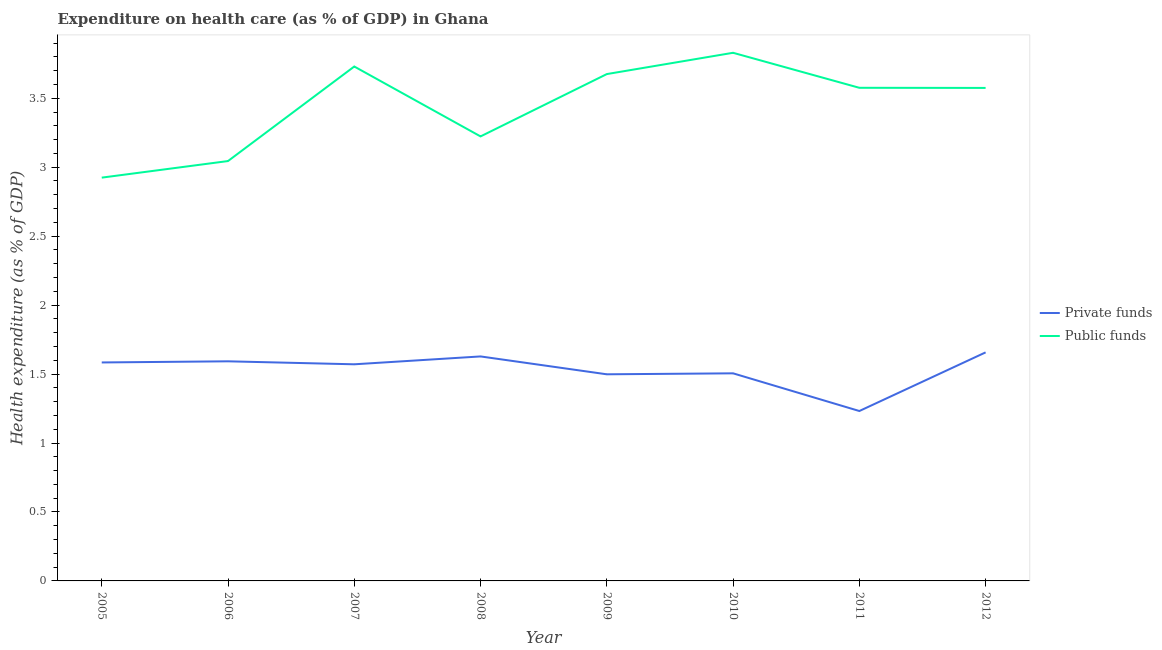How many different coloured lines are there?
Offer a terse response. 2. Does the line corresponding to amount of private funds spent in healthcare intersect with the line corresponding to amount of public funds spent in healthcare?
Offer a terse response. No. What is the amount of private funds spent in healthcare in 2011?
Your answer should be very brief. 1.23. Across all years, what is the maximum amount of public funds spent in healthcare?
Offer a terse response. 3.83. Across all years, what is the minimum amount of private funds spent in healthcare?
Make the answer very short. 1.23. In which year was the amount of private funds spent in healthcare maximum?
Ensure brevity in your answer.  2012. What is the total amount of private funds spent in healthcare in the graph?
Offer a very short reply. 12.27. What is the difference between the amount of public funds spent in healthcare in 2005 and that in 2011?
Provide a succinct answer. -0.65. What is the difference between the amount of public funds spent in healthcare in 2007 and the amount of private funds spent in healthcare in 2005?
Offer a terse response. 2.15. What is the average amount of public funds spent in healthcare per year?
Make the answer very short. 3.45. In the year 2012, what is the difference between the amount of private funds spent in healthcare and amount of public funds spent in healthcare?
Provide a short and direct response. -1.92. In how many years, is the amount of public funds spent in healthcare greater than 1.4 %?
Provide a short and direct response. 8. What is the ratio of the amount of public funds spent in healthcare in 2005 to that in 2009?
Your answer should be compact. 0.8. Is the difference between the amount of public funds spent in healthcare in 2006 and 2010 greater than the difference between the amount of private funds spent in healthcare in 2006 and 2010?
Keep it short and to the point. No. What is the difference between the highest and the second highest amount of public funds spent in healthcare?
Your response must be concise. 0.1. What is the difference between the highest and the lowest amount of private funds spent in healthcare?
Give a very brief answer. 0.43. In how many years, is the amount of private funds spent in healthcare greater than the average amount of private funds spent in healthcare taken over all years?
Your response must be concise. 5. Is the sum of the amount of private funds spent in healthcare in 2005 and 2012 greater than the maximum amount of public funds spent in healthcare across all years?
Provide a short and direct response. No. How many lines are there?
Provide a short and direct response. 2. Does the graph contain any zero values?
Keep it short and to the point. No. Does the graph contain grids?
Provide a succinct answer. No. How many legend labels are there?
Make the answer very short. 2. How are the legend labels stacked?
Your answer should be compact. Vertical. What is the title of the graph?
Give a very brief answer. Expenditure on health care (as % of GDP) in Ghana. What is the label or title of the Y-axis?
Your answer should be very brief. Health expenditure (as % of GDP). What is the Health expenditure (as % of GDP) of Private funds in 2005?
Offer a terse response. 1.58. What is the Health expenditure (as % of GDP) of Public funds in 2005?
Offer a very short reply. 2.92. What is the Health expenditure (as % of GDP) of Private funds in 2006?
Your answer should be compact. 1.59. What is the Health expenditure (as % of GDP) in Public funds in 2006?
Ensure brevity in your answer.  3.04. What is the Health expenditure (as % of GDP) in Private funds in 2007?
Your response must be concise. 1.57. What is the Health expenditure (as % of GDP) of Public funds in 2007?
Make the answer very short. 3.73. What is the Health expenditure (as % of GDP) of Private funds in 2008?
Your answer should be compact. 1.63. What is the Health expenditure (as % of GDP) of Public funds in 2008?
Offer a very short reply. 3.22. What is the Health expenditure (as % of GDP) in Private funds in 2009?
Ensure brevity in your answer.  1.5. What is the Health expenditure (as % of GDP) of Public funds in 2009?
Offer a very short reply. 3.67. What is the Health expenditure (as % of GDP) of Private funds in 2010?
Keep it short and to the point. 1.51. What is the Health expenditure (as % of GDP) of Public funds in 2010?
Make the answer very short. 3.83. What is the Health expenditure (as % of GDP) in Private funds in 2011?
Make the answer very short. 1.23. What is the Health expenditure (as % of GDP) of Public funds in 2011?
Offer a terse response. 3.58. What is the Health expenditure (as % of GDP) of Private funds in 2012?
Your response must be concise. 1.66. What is the Health expenditure (as % of GDP) in Public funds in 2012?
Offer a terse response. 3.57. Across all years, what is the maximum Health expenditure (as % of GDP) of Private funds?
Provide a succinct answer. 1.66. Across all years, what is the maximum Health expenditure (as % of GDP) in Public funds?
Offer a very short reply. 3.83. Across all years, what is the minimum Health expenditure (as % of GDP) in Private funds?
Provide a succinct answer. 1.23. Across all years, what is the minimum Health expenditure (as % of GDP) of Public funds?
Give a very brief answer. 2.92. What is the total Health expenditure (as % of GDP) of Private funds in the graph?
Give a very brief answer. 12.27. What is the total Health expenditure (as % of GDP) of Public funds in the graph?
Provide a short and direct response. 27.58. What is the difference between the Health expenditure (as % of GDP) in Private funds in 2005 and that in 2006?
Provide a succinct answer. -0.01. What is the difference between the Health expenditure (as % of GDP) of Public funds in 2005 and that in 2006?
Give a very brief answer. -0.12. What is the difference between the Health expenditure (as % of GDP) in Private funds in 2005 and that in 2007?
Give a very brief answer. 0.01. What is the difference between the Health expenditure (as % of GDP) of Public funds in 2005 and that in 2007?
Give a very brief answer. -0.81. What is the difference between the Health expenditure (as % of GDP) of Private funds in 2005 and that in 2008?
Keep it short and to the point. -0.04. What is the difference between the Health expenditure (as % of GDP) of Public funds in 2005 and that in 2008?
Offer a terse response. -0.3. What is the difference between the Health expenditure (as % of GDP) in Private funds in 2005 and that in 2009?
Your answer should be compact. 0.09. What is the difference between the Health expenditure (as % of GDP) in Public funds in 2005 and that in 2009?
Give a very brief answer. -0.75. What is the difference between the Health expenditure (as % of GDP) in Private funds in 2005 and that in 2010?
Give a very brief answer. 0.08. What is the difference between the Health expenditure (as % of GDP) in Public funds in 2005 and that in 2010?
Offer a terse response. -0.91. What is the difference between the Health expenditure (as % of GDP) of Private funds in 2005 and that in 2011?
Offer a terse response. 0.35. What is the difference between the Health expenditure (as % of GDP) of Public funds in 2005 and that in 2011?
Provide a succinct answer. -0.65. What is the difference between the Health expenditure (as % of GDP) of Private funds in 2005 and that in 2012?
Ensure brevity in your answer.  -0.07. What is the difference between the Health expenditure (as % of GDP) in Public funds in 2005 and that in 2012?
Your answer should be compact. -0.65. What is the difference between the Health expenditure (as % of GDP) of Private funds in 2006 and that in 2007?
Your answer should be very brief. 0.02. What is the difference between the Health expenditure (as % of GDP) of Public funds in 2006 and that in 2007?
Ensure brevity in your answer.  -0.69. What is the difference between the Health expenditure (as % of GDP) in Private funds in 2006 and that in 2008?
Your response must be concise. -0.04. What is the difference between the Health expenditure (as % of GDP) in Public funds in 2006 and that in 2008?
Provide a succinct answer. -0.18. What is the difference between the Health expenditure (as % of GDP) of Private funds in 2006 and that in 2009?
Ensure brevity in your answer.  0.09. What is the difference between the Health expenditure (as % of GDP) of Public funds in 2006 and that in 2009?
Give a very brief answer. -0.63. What is the difference between the Health expenditure (as % of GDP) in Private funds in 2006 and that in 2010?
Make the answer very short. 0.09. What is the difference between the Health expenditure (as % of GDP) of Public funds in 2006 and that in 2010?
Provide a short and direct response. -0.79. What is the difference between the Health expenditure (as % of GDP) in Private funds in 2006 and that in 2011?
Your answer should be compact. 0.36. What is the difference between the Health expenditure (as % of GDP) of Public funds in 2006 and that in 2011?
Your answer should be compact. -0.53. What is the difference between the Health expenditure (as % of GDP) of Private funds in 2006 and that in 2012?
Your answer should be very brief. -0.06. What is the difference between the Health expenditure (as % of GDP) in Public funds in 2006 and that in 2012?
Your answer should be compact. -0.53. What is the difference between the Health expenditure (as % of GDP) in Private funds in 2007 and that in 2008?
Keep it short and to the point. -0.06. What is the difference between the Health expenditure (as % of GDP) in Public funds in 2007 and that in 2008?
Your answer should be compact. 0.51. What is the difference between the Health expenditure (as % of GDP) in Private funds in 2007 and that in 2009?
Provide a short and direct response. 0.07. What is the difference between the Health expenditure (as % of GDP) in Public funds in 2007 and that in 2009?
Ensure brevity in your answer.  0.05. What is the difference between the Health expenditure (as % of GDP) in Private funds in 2007 and that in 2010?
Ensure brevity in your answer.  0.07. What is the difference between the Health expenditure (as % of GDP) of Public funds in 2007 and that in 2010?
Offer a terse response. -0.1. What is the difference between the Health expenditure (as % of GDP) of Private funds in 2007 and that in 2011?
Your response must be concise. 0.34. What is the difference between the Health expenditure (as % of GDP) of Public funds in 2007 and that in 2011?
Provide a short and direct response. 0.15. What is the difference between the Health expenditure (as % of GDP) of Private funds in 2007 and that in 2012?
Keep it short and to the point. -0.09. What is the difference between the Health expenditure (as % of GDP) in Public funds in 2007 and that in 2012?
Your answer should be very brief. 0.16. What is the difference between the Health expenditure (as % of GDP) in Private funds in 2008 and that in 2009?
Offer a terse response. 0.13. What is the difference between the Health expenditure (as % of GDP) of Public funds in 2008 and that in 2009?
Make the answer very short. -0.45. What is the difference between the Health expenditure (as % of GDP) in Private funds in 2008 and that in 2010?
Provide a succinct answer. 0.12. What is the difference between the Health expenditure (as % of GDP) of Public funds in 2008 and that in 2010?
Your response must be concise. -0.61. What is the difference between the Health expenditure (as % of GDP) in Private funds in 2008 and that in 2011?
Your answer should be compact. 0.4. What is the difference between the Health expenditure (as % of GDP) in Public funds in 2008 and that in 2011?
Provide a short and direct response. -0.35. What is the difference between the Health expenditure (as % of GDP) in Private funds in 2008 and that in 2012?
Offer a terse response. -0.03. What is the difference between the Health expenditure (as % of GDP) in Public funds in 2008 and that in 2012?
Make the answer very short. -0.35. What is the difference between the Health expenditure (as % of GDP) of Private funds in 2009 and that in 2010?
Your answer should be very brief. -0.01. What is the difference between the Health expenditure (as % of GDP) of Public funds in 2009 and that in 2010?
Your response must be concise. -0.15. What is the difference between the Health expenditure (as % of GDP) of Private funds in 2009 and that in 2011?
Provide a short and direct response. 0.27. What is the difference between the Health expenditure (as % of GDP) of Public funds in 2009 and that in 2011?
Make the answer very short. 0.1. What is the difference between the Health expenditure (as % of GDP) of Private funds in 2009 and that in 2012?
Offer a terse response. -0.16. What is the difference between the Health expenditure (as % of GDP) of Public funds in 2009 and that in 2012?
Your response must be concise. 0.1. What is the difference between the Health expenditure (as % of GDP) in Private funds in 2010 and that in 2011?
Ensure brevity in your answer.  0.27. What is the difference between the Health expenditure (as % of GDP) in Public funds in 2010 and that in 2011?
Ensure brevity in your answer.  0.25. What is the difference between the Health expenditure (as % of GDP) of Private funds in 2010 and that in 2012?
Ensure brevity in your answer.  -0.15. What is the difference between the Health expenditure (as % of GDP) of Public funds in 2010 and that in 2012?
Your answer should be very brief. 0.25. What is the difference between the Health expenditure (as % of GDP) in Private funds in 2011 and that in 2012?
Give a very brief answer. -0.43. What is the difference between the Health expenditure (as % of GDP) in Public funds in 2011 and that in 2012?
Provide a short and direct response. 0. What is the difference between the Health expenditure (as % of GDP) in Private funds in 2005 and the Health expenditure (as % of GDP) in Public funds in 2006?
Your answer should be compact. -1.46. What is the difference between the Health expenditure (as % of GDP) of Private funds in 2005 and the Health expenditure (as % of GDP) of Public funds in 2007?
Provide a short and direct response. -2.15. What is the difference between the Health expenditure (as % of GDP) in Private funds in 2005 and the Health expenditure (as % of GDP) in Public funds in 2008?
Ensure brevity in your answer.  -1.64. What is the difference between the Health expenditure (as % of GDP) of Private funds in 2005 and the Health expenditure (as % of GDP) of Public funds in 2009?
Offer a terse response. -2.09. What is the difference between the Health expenditure (as % of GDP) in Private funds in 2005 and the Health expenditure (as % of GDP) in Public funds in 2010?
Your answer should be very brief. -2.25. What is the difference between the Health expenditure (as % of GDP) in Private funds in 2005 and the Health expenditure (as % of GDP) in Public funds in 2011?
Offer a very short reply. -1.99. What is the difference between the Health expenditure (as % of GDP) in Private funds in 2005 and the Health expenditure (as % of GDP) in Public funds in 2012?
Make the answer very short. -1.99. What is the difference between the Health expenditure (as % of GDP) of Private funds in 2006 and the Health expenditure (as % of GDP) of Public funds in 2007?
Offer a very short reply. -2.14. What is the difference between the Health expenditure (as % of GDP) in Private funds in 2006 and the Health expenditure (as % of GDP) in Public funds in 2008?
Your answer should be compact. -1.63. What is the difference between the Health expenditure (as % of GDP) of Private funds in 2006 and the Health expenditure (as % of GDP) of Public funds in 2009?
Your response must be concise. -2.08. What is the difference between the Health expenditure (as % of GDP) in Private funds in 2006 and the Health expenditure (as % of GDP) in Public funds in 2010?
Give a very brief answer. -2.24. What is the difference between the Health expenditure (as % of GDP) of Private funds in 2006 and the Health expenditure (as % of GDP) of Public funds in 2011?
Offer a terse response. -1.98. What is the difference between the Health expenditure (as % of GDP) in Private funds in 2006 and the Health expenditure (as % of GDP) in Public funds in 2012?
Offer a very short reply. -1.98. What is the difference between the Health expenditure (as % of GDP) of Private funds in 2007 and the Health expenditure (as % of GDP) of Public funds in 2008?
Provide a short and direct response. -1.65. What is the difference between the Health expenditure (as % of GDP) of Private funds in 2007 and the Health expenditure (as % of GDP) of Public funds in 2009?
Give a very brief answer. -2.1. What is the difference between the Health expenditure (as % of GDP) in Private funds in 2007 and the Health expenditure (as % of GDP) in Public funds in 2010?
Your response must be concise. -2.26. What is the difference between the Health expenditure (as % of GDP) of Private funds in 2007 and the Health expenditure (as % of GDP) of Public funds in 2011?
Your answer should be very brief. -2. What is the difference between the Health expenditure (as % of GDP) in Private funds in 2007 and the Health expenditure (as % of GDP) in Public funds in 2012?
Offer a very short reply. -2. What is the difference between the Health expenditure (as % of GDP) in Private funds in 2008 and the Health expenditure (as % of GDP) in Public funds in 2009?
Give a very brief answer. -2.05. What is the difference between the Health expenditure (as % of GDP) of Private funds in 2008 and the Health expenditure (as % of GDP) of Public funds in 2010?
Offer a very short reply. -2.2. What is the difference between the Health expenditure (as % of GDP) of Private funds in 2008 and the Health expenditure (as % of GDP) of Public funds in 2011?
Ensure brevity in your answer.  -1.95. What is the difference between the Health expenditure (as % of GDP) of Private funds in 2008 and the Health expenditure (as % of GDP) of Public funds in 2012?
Provide a short and direct response. -1.95. What is the difference between the Health expenditure (as % of GDP) of Private funds in 2009 and the Health expenditure (as % of GDP) of Public funds in 2010?
Give a very brief answer. -2.33. What is the difference between the Health expenditure (as % of GDP) of Private funds in 2009 and the Health expenditure (as % of GDP) of Public funds in 2011?
Give a very brief answer. -2.08. What is the difference between the Health expenditure (as % of GDP) of Private funds in 2009 and the Health expenditure (as % of GDP) of Public funds in 2012?
Make the answer very short. -2.08. What is the difference between the Health expenditure (as % of GDP) in Private funds in 2010 and the Health expenditure (as % of GDP) in Public funds in 2011?
Provide a short and direct response. -2.07. What is the difference between the Health expenditure (as % of GDP) in Private funds in 2010 and the Health expenditure (as % of GDP) in Public funds in 2012?
Your answer should be very brief. -2.07. What is the difference between the Health expenditure (as % of GDP) of Private funds in 2011 and the Health expenditure (as % of GDP) of Public funds in 2012?
Offer a very short reply. -2.34. What is the average Health expenditure (as % of GDP) of Private funds per year?
Ensure brevity in your answer.  1.53. What is the average Health expenditure (as % of GDP) in Public funds per year?
Offer a very short reply. 3.45. In the year 2005, what is the difference between the Health expenditure (as % of GDP) in Private funds and Health expenditure (as % of GDP) in Public funds?
Provide a short and direct response. -1.34. In the year 2006, what is the difference between the Health expenditure (as % of GDP) in Private funds and Health expenditure (as % of GDP) in Public funds?
Make the answer very short. -1.45. In the year 2007, what is the difference between the Health expenditure (as % of GDP) of Private funds and Health expenditure (as % of GDP) of Public funds?
Provide a short and direct response. -2.16. In the year 2008, what is the difference between the Health expenditure (as % of GDP) in Private funds and Health expenditure (as % of GDP) in Public funds?
Offer a very short reply. -1.6. In the year 2009, what is the difference between the Health expenditure (as % of GDP) of Private funds and Health expenditure (as % of GDP) of Public funds?
Provide a succinct answer. -2.18. In the year 2010, what is the difference between the Health expenditure (as % of GDP) in Private funds and Health expenditure (as % of GDP) in Public funds?
Your response must be concise. -2.32. In the year 2011, what is the difference between the Health expenditure (as % of GDP) in Private funds and Health expenditure (as % of GDP) in Public funds?
Keep it short and to the point. -2.34. In the year 2012, what is the difference between the Health expenditure (as % of GDP) in Private funds and Health expenditure (as % of GDP) in Public funds?
Your answer should be very brief. -1.92. What is the ratio of the Health expenditure (as % of GDP) of Private funds in 2005 to that in 2006?
Make the answer very short. 0.99. What is the ratio of the Health expenditure (as % of GDP) in Public funds in 2005 to that in 2006?
Give a very brief answer. 0.96. What is the ratio of the Health expenditure (as % of GDP) of Private funds in 2005 to that in 2007?
Offer a terse response. 1.01. What is the ratio of the Health expenditure (as % of GDP) of Public funds in 2005 to that in 2007?
Make the answer very short. 0.78. What is the ratio of the Health expenditure (as % of GDP) of Private funds in 2005 to that in 2008?
Keep it short and to the point. 0.97. What is the ratio of the Health expenditure (as % of GDP) of Public funds in 2005 to that in 2008?
Provide a short and direct response. 0.91. What is the ratio of the Health expenditure (as % of GDP) of Private funds in 2005 to that in 2009?
Provide a succinct answer. 1.06. What is the ratio of the Health expenditure (as % of GDP) in Public funds in 2005 to that in 2009?
Your answer should be compact. 0.8. What is the ratio of the Health expenditure (as % of GDP) of Private funds in 2005 to that in 2010?
Keep it short and to the point. 1.05. What is the ratio of the Health expenditure (as % of GDP) in Public funds in 2005 to that in 2010?
Your answer should be very brief. 0.76. What is the ratio of the Health expenditure (as % of GDP) of Private funds in 2005 to that in 2011?
Give a very brief answer. 1.29. What is the ratio of the Health expenditure (as % of GDP) of Public funds in 2005 to that in 2011?
Provide a succinct answer. 0.82. What is the ratio of the Health expenditure (as % of GDP) of Private funds in 2005 to that in 2012?
Your answer should be compact. 0.96. What is the ratio of the Health expenditure (as % of GDP) in Public funds in 2005 to that in 2012?
Offer a very short reply. 0.82. What is the ratio of the Health expenditure (as % of GDP) in Private funds in 2006 to that in 2007?
Your answer should be compact. 1.01. What is the ratio of the Health expenditure (as % of GDP) of Public funds in 2006 to that in 2007?
Keep it short and to the point. 0.82. What is the ratio of the Health expenditure (as % of GDP) of Private funds in 2006 to that in 2008?
Offer a very short reply. 0.98. What is the ratio of the Health expenditure (as % of GDP) in Public funds in 2006 to that in 2008?
Your answer should be compact. 0.94. What is the ratio of the Health expenditure (as % of GDP) of Private funds in 2006 to that in 2009?
Your answer should be very brief. 1.06. What is the ratio of the Health expenditure (as % of GDP) of Public funds in 2006 to that in 2009?
Keep it short and to the point. 0.83. What is the ratio of the Health expenditure (as % of GDP) in Private funds in 2006 to that in 2010?
Ensure brevity in your answer.  1.06. What is the ratio of the Health expenditure (as % of GDP) of Public funds in 2006 to that in 2010?
Provide a short and direct response. 0.8. What is the ratio of the Health expenditure (as % of GDP) of Private funds in 2006 to that in 2011?
Your response must be concise. 1.29. What is the ratio of the Health expenditure (as % of GDP) of Public funds in 2006 to that in 2011?
Offer a terse response. 0.85. What is the ratio of the Health expenditure (as % of GDP) in Private funds in 2006 to that in 2012?
Give a very brief answer. 0.96. What is the ratio of the Health expenditure (as % of GDP) of Public funds in 2006 to that in 2012?
Ensure brevity in your answer.  0.85. What is the ratio of the Health expenditure (as % of GDP) in Private funds in 2007 to that in 2008?
Offer a terse response. 0.96. What is the ratio of the Health expenditure (as % of GDP) of Public funds in 2007 to that in 2008?
Provide a short and direct response. 1.16. What is the ratio of the Health expenditure (as % of GDP) of Private funds in 2007 to that in 2009?
Offer a very short reply. 1.05. What is the ratio of the Health expenditure (as % of GDP) in Public funds in 2007 to that in 2009?
Ensure brevity in your answer.  1.01. What is the ratio of the Health expenditure (as % of GDP) in Private funds in 2007 to that in 2010?
Provide a short and direct response. 1.04. What is the ratio of the Health expenditure (as % of GDP) in Public funds in 2007 to that in 2010?
Offer a terse response. 0.97. What is the ratio of the Health expenditure (as % of GDP) of Private funds in 2007 to that in 2011?
Make the answer very short. 1.27. What is the ratio of the Health expenditure (as % of GDP) in Public funds in 2007 to that in 2011?
Ensure brevity in your answer.  1.04. What is the ratio of the Health expenditure (as % of GDP) in Private funds in 2007 to that in 2012?
Offer a very short reply. 0.95. What is the ratio of the Health expenditure (as % of GDP) of Public funds in 2007 to that in 2012?
Make the answer very short. 1.04. What is the ratio of the Health expenditure (as % of GDP) of Private funds in 2008 to that in 2009?
Keep it short and to the point. 1.09. What is the ratio of the Health expenditure (as % of GDP) of Public funds in 2008 to that in 2009?
Your response must be concise. 0.88. What is the ratio of the Health expenditure (as % of GDP) in Private funds in 2008 to that in 2010?
Keep it short and to the point. 1.08. What is the ratio of the Health expenditure (as % of GDP) of Public funds in 2008 to that in 2010?
Your answer should be compact. 0.84. What is the ratio of the Health expenditure (as % of GDP) of Private funds in 2008 to that in 2011?
Provide a succinct answer. 1.32. What is the ratio of the Health expenditure (as % of GDP) in Public funds in 2008 to that in 2011?
Provide a short and direct response. 0.9. What is the ratio of the Health expenditure (as % of GDP) in Private funds in 2008 to that in 2012?
Provide a succinct answer. 0.98. What is the ratio of the Health expenditure (as % of GDP) of Public funds in 2008 to that in 2012?
Give a very brief answer. 0.9. What is the ratio of the Health expenditure (as % of GDP) of Private funds in 2009 to that in 2010?
Provide a short and direct response. 1. What is the ratio of the Health expenditure (as % of GDP) of Public funds in 2009 to that in 2010?
Provide a succinct answer. 0.96. What is the ratio of the Health expenditure (as % of GDP) of Private funds in 2009 to that in 2011?
Your answer should be very brief. 1.22. What is the ratio of the Health expenditure (as % of GDP) of Public funds in 2009 to that in 2011?
Offer a terse response. 1.03. What is the ratio of the Health expenditure (as % of GDP) in Private funds in 2009 to that in 2012?
Keep it short and to the point. 0.9. What is the ratio of the Health expenditure (as % of GDP) in Public funds in 2009 to that in 2012?
Give a very brief answer. 1.03. What is the ratio of the Health expenditure (as % of GDP) of Private funds in 2010 to that in 2011?
Your answer should be very brief. 1.22. What is the ratio of the Health expenditure (as % of GDP) in Public funds in 2010 to that in 2011?
Your answer should be very brief. 1.07. What is the ratio of the Health expenditure (as % of GDP) in Private funds in 2010 to that in 2012?
Give a very brief answer. 0.91. What is the ratio of the Health expenditure (as % of GDP) of Public funds in 2010 to that in 2012?
Keep it short and to the point. 1.07. What is the ratio of the Health expenditure (as % of GDP) in Private funds in 2011 to that in 2012?
Your response must be concise. 0.74. What is the difference between the highest and the second highest Health expenditure (as % of GDP) in Private funds?
Give a very brief answer. 0.03. What is the difference between the highest and the second highest Health expenditure (as % of GDP) of Public funds?
Give a very brief answer. 0.1. What is the difference between the highest and the lowest Health expenditure (as % of GDP) in Private funds?
Your response must be concise. 0.43. What is the difference between the highest and the lowest Health expenditure (as % of GDP) of Public funds?
Your answer should be very brief. 0.91. 